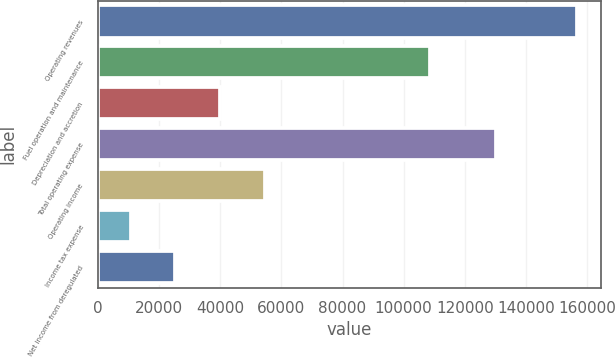Convert chart to OTSL. <chart><loc_0><loc_0><loc_500><loc_500><bar_chart><fcel>Operating revenues<fcel>Fuel operation and maintenance<fcel>Depreciation and accretion<fcel>Total operating expense<fcel>Operating income<fcel>Income tax expense<fcel>Net income from deregulated<nl><fcel>156673<fcel>108755<fcel>39904.2<fcel>130310<fcel>54500.3<fcel>10712<fcel>25308.1<nl></chart> 